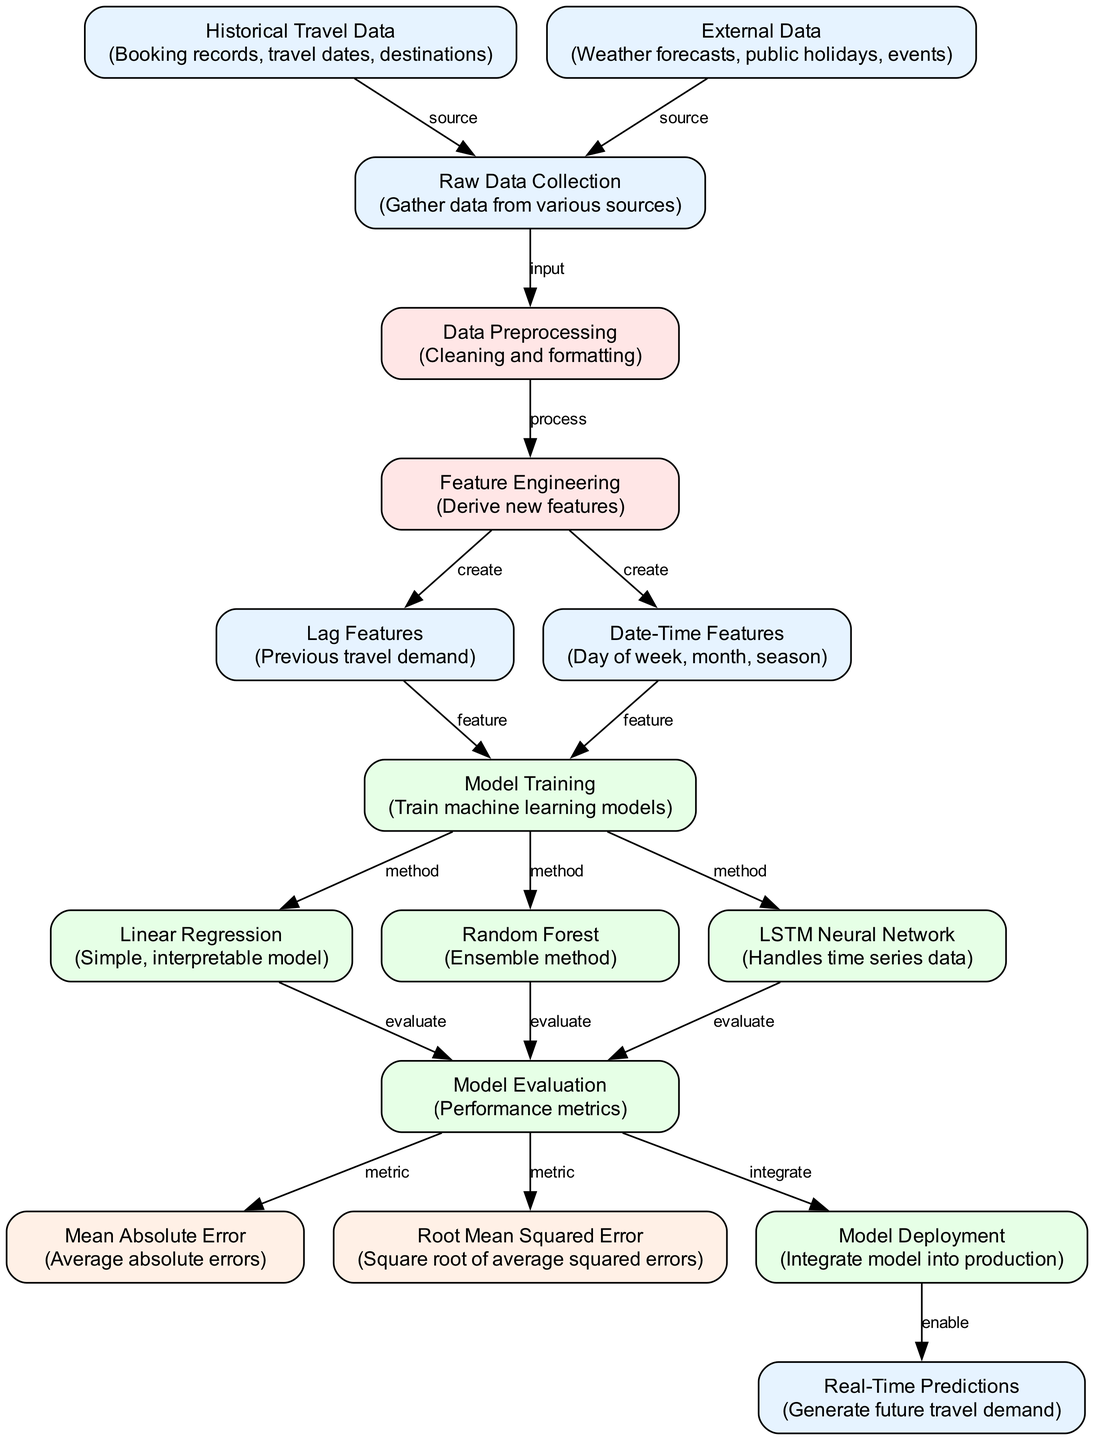What is the first step in the diagram? The first step is "Raw Data Collection," as indicated in the diagram where this node is at the top and serves as the starting point for the entire process.
Answer: Raw Data Collection How many machine learning models are represented in the diagram? The diagram shows three different machine learning models: Linear Regression, Random Forest, and LSTM Neural Network. Thus, by counting those model nodes, we can determine the total.
Answer: 3 What external data influences the raw data collection? The diagram indicates that "Weather forecasts," "public holidays," and "events" are external data sources that contribute to the raw data via the "External Data" node.
Answer: Weather forecasts, public holidays, events Which node is responsible for model evaluation? The node labeled "Model Evaluation" is designated for evaluating the performance of the machine learning models, representing a crucial assessment stage.
Answer: Model Evaluation From which nodes are lag features created? The "Feature Engineering" node leads to the creation of "Lag Features," indicating that lag features derive from the processed data in the preceding step, specifically using historical data.
Answer: Historical Travel Data Which model has an ensemble technique? The "Random Forest" model, indicated in the diagram, is identified as using an ensemble method for predictions, distinguishing it from other modeling techniques presented.
Answer: Random Forest What is the output after the Model Deployment stage? "Real-Time Predictions" is directly confirmed as the output following the "Model Deployment" stage, indicating the model has been successfully integrated and is now operational.
Answer: Real-Time Predictions What are the evaluation metrics mentioned in the diagram? The diagram lists "Mean Absolute Error" and "Root Mean Squared Error" as metrics used to evaluate the performance of the models, providing measures for accuracy in predictions.
Answer: Mean Absolute Error, Root Mean Squared Error Which process follows Data Preprocessing in the diagram? After "Data Preprocessing," the next step in the workflow is "Feature Engineering," which indicates that new features are derived upon completing the preprocessing tasks.
Answer: Feature Engineering 